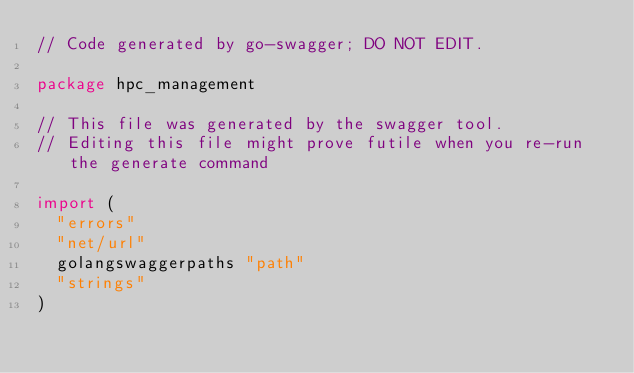Convert code to text. <code><loc_0><loc_0><loc_500><loc_500><_Go_>// Code generated by go-swagger; DO NOT EDIT.

package hpc_management

// This file was generated by the swagger tool.
// Editing this file might prove futile when you re-run the generate command

import (
	"errors"
	"net/url"
	golangswaggerpaths "path"
	"strings"
)
</code> 